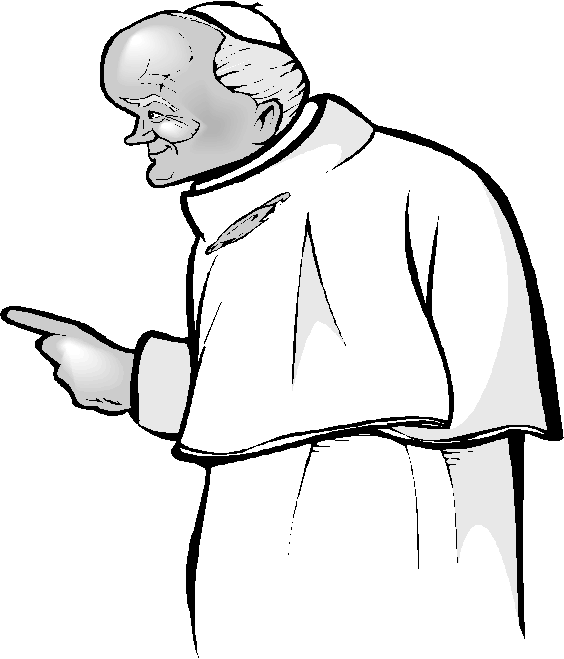What role do you think the figure might be playing based on his attire and expression? The figure's attire, which resembles religious vestments, and his serious, focused expression suggest that he might be playing the role of a religious leader or a high-ranking clerical figure. His stern demeanor and authoritative gesture could indicate that he is delivering an important message, teaching a lesson, or addressing an audience within a solemn, formal context. What might the figure be pointing at, and what does this gesture imply? The figure's pointing gesture could imply several things depending on context. He might be directing attention to something of importance, giving instructions, or emphasizing a key point in a speech or lesson. The gesture enhances his authoritative presence, making it seem like he is guiding or leading others, reinforcing the perception of him as a knowledgeable and commanding figure. Imagine the figure in a completely different context. What would his posture and expression suggest if he were in a fantasy world? In a fantasy world, the figure's upright posture and pointing gesture could suggest he is a wise and ancient sorcerer or a legendary hero imparting crucial knowledge or casting a powerful spell. His serious expression might indicate the gravity of a situation, perhaps a forewarning of impending danger or the delivery of a prophecy. This fantastical context adds a layer of mystique and grandeur to his authoritative demeanor.  Can you propose a detailed backstory for this figure? In a distant land steeped in tradition and ancient customs, the figure is known as Grandmaster Elros, a revered sage who has dedicated his life to the pursuit and dissemination of knowledge. His journey began as a humble scholar in the Great Library of Solara, where he unearthed lost manuscripts containing the secrets of the universe. Driven by unquenchable curiosity and a deep sense of duty, Elros traveled far and wide, learning from every culture, mastering every craft, and absorbing wisdom from the natural world. Upon his return, he was appointed as the High Council's Chief Advisor, a role in which he has guided kings, strategists, and common folk alike. His commanding presence is a testament to years of experience and the heavy responsibilities he shoulders. Every gesture is imbued with the weight of his accumulated wisdom, and his words carry the authority of someone who has devoted their life to the betterment of others. His sage-like demeanor, characterized by his stern facial expression and purposeful posture, commands respect and inspires those around him to strive for greatness. 